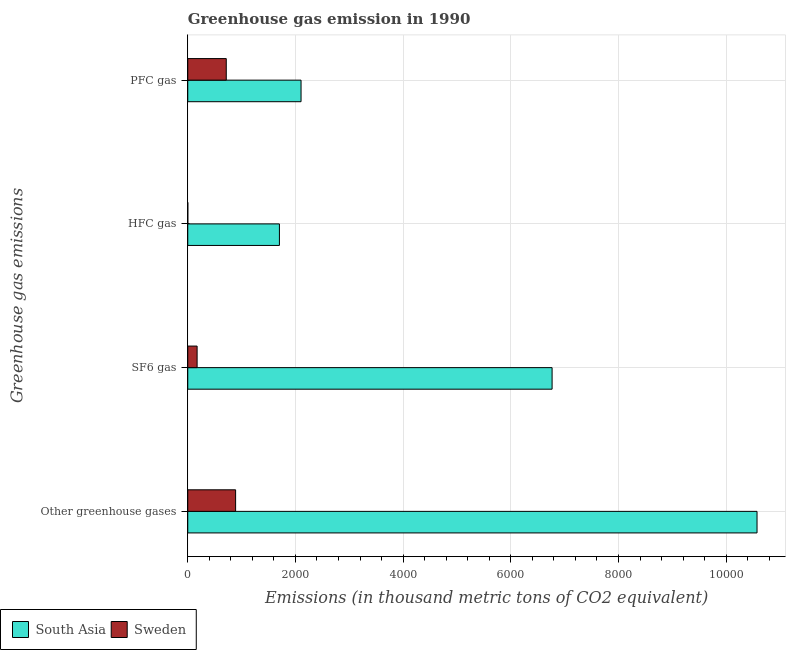Are the number of bars per tick equal to the number of legend labels?
Provide a short and direct response. Yes. Are the number of bars on each tick of the Y-axis equal?
Your answer should be compact. Yes. How many bars are there on the 1st tick from the bottom?
Your answer should be very brief. 2. What is the label of the 1st group of bars from the top?
Keep it short and to the point. PFC gas. What is the emission of sf6 gas in Sweden?
Ensure brevity in your answer.  173.5. Across all countries, what is the maximum emission of greenhouse gases?
Offer a very short reply. 1.06e+04. In which country was the emission of pfc gas maximum?
Offer a terse response. South Asia. In which country was the emission of pfc gas minimum?
Your response must be concise. Sweden. What is the total emission of greenhouse gases in the graph?
Offer a terse response. 1.15e+04. What is the difference between the emission of sf6 gas in Sweden and that in South Asia?
Make the answer very short. -6593. What is the difference between the emission of greenhouse gases in South Asia and the emission of pfc gas in Sweden?
Keep it short and to the point. 9857.7. What is the average emission of pfc gas per country?
Your answer should be very brief. 1409.45. What is the difference between the emission of sf6 gas and emission of pfc gas in South Asia?
Give a very brief answer. 4662.5. What is the ratio of the emission of sf6 gas in South Asia to that in Sweden?
Make the answer very short. 39. Is the emission of pfc gas in Sweden less than that in South Asia?
Your answer should be compact. Yes. Is the difference between the emission of pfc gas in South Asia and Sweden greater than the difference between the emission of hfc gas in South Asia and Sweden?
Offer a terse response. No. What is the difference between the highest and the second highest emission of pfc gas?
Keep it short and to the point. 1389.1. What is the difference between the highest and the lowest emission of sf6 gas?
Your answer should be very brief. 6593. In how many countries, is the emission of pfc gas greater than the average emission of pfc gas taken over all countries?
Your answer should be very brief. 1. Is the sum of the emission of greenhouse gases in Sweden and South Asia greater than the maximum emission of pfc gas across all countries?
Your answer should be very brief. Yes. Is it the case that in every country, the sum of the emission of sf6 gas and emission of pfc gas is greater than the sum of emission of greenhouse gases and emission of hfc gas?
Give a very brief answer. No. Is it the case that in every country, the sum of the emission of greenhouse gases and emission of sf6 gas is greater than the emission of hfc gas?
Provide a short and direct response. Yes. How many bars are there?
Offer a terse response. 8. Are all the bars in the graph horizontal?
Keep it short and to the point. Yes. What is the difference between two consecutive major ticks on the X-axis?
Give a very brief answer. 2000. Does the graph contain any zero values?
Offer a terse response. No. Does the graph contain grids?
Offer a terse response. Yes. Where does the legend appear in the graph?
Your answer should be very brief. Bottom left. How many legend labels are there?
Your answer should be very brief. 2. What is the title of the graph?
Offer a very short reply. Greenhouse gas emission in 1990. Does "Iran" appear as one of the legend labels in the graph?
Ensure brevity in your answer.  No. What is the label or title of the X-axis?
Give a very brief answer. Emissions (in thousand metric tons of CO2 equivalent). What is the label or title of the Y-axis?
Offer a very short reply. Greenhouse gas emissions. What is the Emissions (in thousand metric tons of CO2 equivalent) in South Asia in Other greenhouse gases?
Your answer should be compact. 1.06e+04. What is the Emissions (in thousand metric tons of CO2 equivalent) in Sweden in Other greenhouse gases?
Your answer should be very brief. 888.6. What is the Emissions (in thousand metric tons of CO2 equivalent) of South Asia in SF6 gas?
Provide a short and direct response. 6766.5. What is the Emissions (in thousand metric tons of CO2 equivalent) in Sweden in SF6 gas?
Offer a very short reply. 173.5. What is the Emissions (in thousand metric tons of CO2 equivalent) in South Asia in HFC gas?
Offer a very short reply. 1702.1. What is the Emissions (in thousand metric tons of CO2 equivalent) of South Asia in PFC gas?
Your response must be concise. 2104. What is the Emissions (in thousand metric tons of CO2 equivalent) in Sweden in PFC gas?
Ensure brevity in your answer.  714.9. Across all Greenhouse gas emissions, what is the maximum Emissions (in thousand metric tons of CO2 equivalent) in South Asia?
Keep it short and to the point. 1.06e+04. Across all Greenhouse gas emissions, what is the maximum Emissions (in thousand metric tons of CO2 equivalent) in Sweden?
Make the answer very short. 888.6. Across all Greenhouse gas emissions, what is the minimum Emissions (in thousand metric tons of CO2 equivalent) in South Asia?
Offer a very short reply. 1702.1. Across all Greenhouse gas emissions, what is the minimum Emissions (in thousand metric tons of CO2 equivalent) of Sweden?
Provide a succinct answer. 0.2. What is the total Emissions (in thousand metric tons of CO2 equivalent) of South Asia in the graph?
Offer a terse response. 2.11e+04. What is the total Emissions (in thousand metric tons of CO2 equivalent) in Sweden in the graph?
Your answer should be very brief. 1777.2. What is the difference between the Emissions (in thousand metric tons of CO2 equivalent) of South Asia in Other greenhouse gases and that in SF6 gas?
Provide a succinct answer. 3806.1. What is the difference between the Emissions (in thousand metric tons of CO2 equivalent) of Sweden in Other greenhouse gases and that in SF6 gas?
Provide a succinct answer. 715.1. What is the difference between the Emissions (in thousand metric tons of CO2 equivalent) of South Asia in Other greenhouse gases and that in HFC gas?
Offer a terse response. 8870.5. What is the difference between the Emissions (in thousand metric tons of CO2 equivalent) in Sweden in Other greenhouse gases and that in HFC gas?
Your answer should be compact. 888.4. What is the difference between the Emissions (in thousand metric tons of CO2 equivalent) in South Asia in Other greenhouse gases and that in PFC gas?
Offer a terse response. 8468.6. What is the difference between the Emissions (in thousand metric tons of CO2 equivalent) in Sweden in Other greenhouse gases and that in PFC gas?
Provide a succinct answer. 173.7. What is the difference between the Emissions (in thousand metric tons of CO2 equivalent) in South Asia in SF6 gas and that in HFC gas?
Give a very brief answer. 5064.4. What is the difference between the Emissions (in thousand metric tons of CO2 equivalent) in Sweden in SF6 gas and that in HFC gas?
Your answer should be very brief. 173.3. What is the difference between the Emissions (in thousand metric tons of CO2 equivalent) in South Asia in SF6 gas and that in PFC gas?
Provide a short and direct response. 4662.5. What is the difference between the Emissions (in thousand metric tons of CO2 equivalent) in Sweden in SF6 gas and that in PFC gas?
Offer a very short reply. -541.4. What is the difference between the Emissions (in thousand metric tons of CO2 equivalent) of South Asia in HFC gas and that in PFC gas?
Provide a short and direct response. -401.9. What is the difference between the Emissions (in thousand metric tons of CO2 equivalent) in Sweden in HFC gas and that in PFC gas?
Give a very brief answer. -714.7. What is the difference between the Emissions (in thousand metric tons of CO2 equivalent) in South Asia in Other greenhouse gases and the Emissions (in thousand metric tons of CO2 equivalent) in Sweden in SF6 gas?
Your response must be concise. 1.04e+04. What is the difference between the Emissions (in thousand metric tons of CO2 equivalent) of South Asia in Other greenhouse gases and the Emissions (in thousand metric tons of CO2 equivalent) of Sweden in HFC gas?
Provide a succinct answer. 1.06e+04. What is the difference between the Emissions (in thousand metric tons of CO2 equivalent) in South Asia in Other greenhouse gases and the Emissions (in thousand metric tons of CO2 equivalent) in Sweden in PFC gas?
Your answer should be compact. 9857.7. What is the difference between the Emissions (in thousand metric tons of CO2 equivalent) of South Asia in SF6 gas and the Emissions (in thousand metric tons of CO2 equivalent) of Sweden in HFC gas?
Offer a terse response. 6766.3. What is the difference between the Emissions (in thousand metric tons of CO2 equivalent) of South Asia in SF6 gas and the Emissions (in thousand metric tons of CO2 equivalent) of Sweden in PFC gas?
Keep it short and to the point. 6051.6. What is the difference between the Emissions (in thousand metric tons of CO2 equivalent) in South Asia in HFC gas and the Emissions (in thousand metric tons of CO2 equivalent) in Sweden in PFC gas?
Keep it short and to the point. 987.2. What is the average Emissions (in thousand metric tons of CO2 equivalent) in South Asia per Greenhouse gas emissions?
Your answer should be compact. 5286.3. What is the average Emissions (in thousand metric tons of CO2 equivalent) of Sweden per Greenhouse gas emissions?
Give a very brief answer. 444.3. What is the difference between the Emissions (in thousand metric tons of CO2 equivalent) of South Asia and Emissions (in thousand metric tons of CO2 equivalent) of Sweden in Other greenhouse gases?
Give a very brief answer. 9684. What is the difference between the Emissions (in thousand metric tons of CO2 equivalent) of South Asia and Emissions (in thousand metric tons of CO2 equivalent) of Sweden in SF6 gas?
Keep it short and to the point. 6593. What is the difference between the Emissions (in thousand metric tons of CO2 equivalent) of South Asia and Emissions (in thousand metric tons of CO2 equivalent) of Sweden in HFC gas?
Offer a very short reply. 1701.9. What is the difference between the Emissions (in thousand metric tons of CO2 equivalent) of South Asia and Emissions (in thousand metric tons of CO2 equivalent) of Sweden in PFC gas?
Offer a very short reply. 1389.1. What is the ratio of the Emissions (in thousand metric tons of CO2 equivalent) of South Asia in Other greenhouse gases to that in SF6 gas?
Keep it short and to the point. 1.56. What is the ratio of the Emissions (in thousand metric tons of CO2 equivalent) of Sweden in Other greenhouse gases to that in SF6 gas?
Your answer should be compact. 5.12. What is the ratio of the Emissions (in thousand metric tons of CO2 equivalent) of South Asia in Other greenhouse gases to that in HFC gas?
Provide a short and direct response. 6.21. What is the ratio of the Emissions (in thousand metric tons of CO2 equivalent) of Sweden in Other greenhouse gases to that in HFC gas?
Your response must be concise. 4443. What is the ratio of the Emissions (in thousand metric tons of CO2 equivalent) in South Asia in Other greenhouse gases to that in PFC gas?
Provide a short and direct response. 5.03. What is the ratio of the Emissions (in thousand metric tons of CO2 equivalent) in Sweden in Other greenhouse gases to that in PFC gas?
Keep it short and to the point. 1.24. What is the ratio of the Emissions (in thousand metric tons of CO2 equivalent) in South Asia in SF6 gas to that in HFC gas?
Offer a terse response. 3.98. What is the ratio of the Emissions (in thousand metric tons of CO2 equivalent) in Sweden in SF6 gas to that in HFC gas?
Your answer should be compact. 867.5. What is the ratio of the Emissions (in thousand metric tons of CO2 equivalent) in South Asia in SF6 gas to that in PFC gas?
Make the answer very short. 3.22. What is the ratio of the Emissions (in thousand metric tons of CO2 equivalent) of Sweden in SF6 gas to that in PFC gas?
Your answer should be very brief. 0.24. What is the ratio of the Emissions (in thousand metric tons of CO2 equivalent) of South Asia in HFC gas to that in PFC gas?
Provide a short and direct response. 0.81. What is the difference between the highest and the second highest Emissions (in thousand metric tons of CO2 equivalent) in South Asia?
Offer a very short reply. 3806.1. What is the difference between the highest and the second highest Emissions (in thousand metric tons of CO2 equivalent) in Sweden?
Give a very brief answer. 173.7. What is the difference between the highest and the lowest Emissions (in thousand metric tons of CO2 equivalent) in South Asia?
Keep it short and to the point. 8870.5. What is the difference between the highest and the lowest Emissions (in thousand metric tons of CO2 equivalent) of Sweden?
Ensure brevity in your answer.  888.4. 